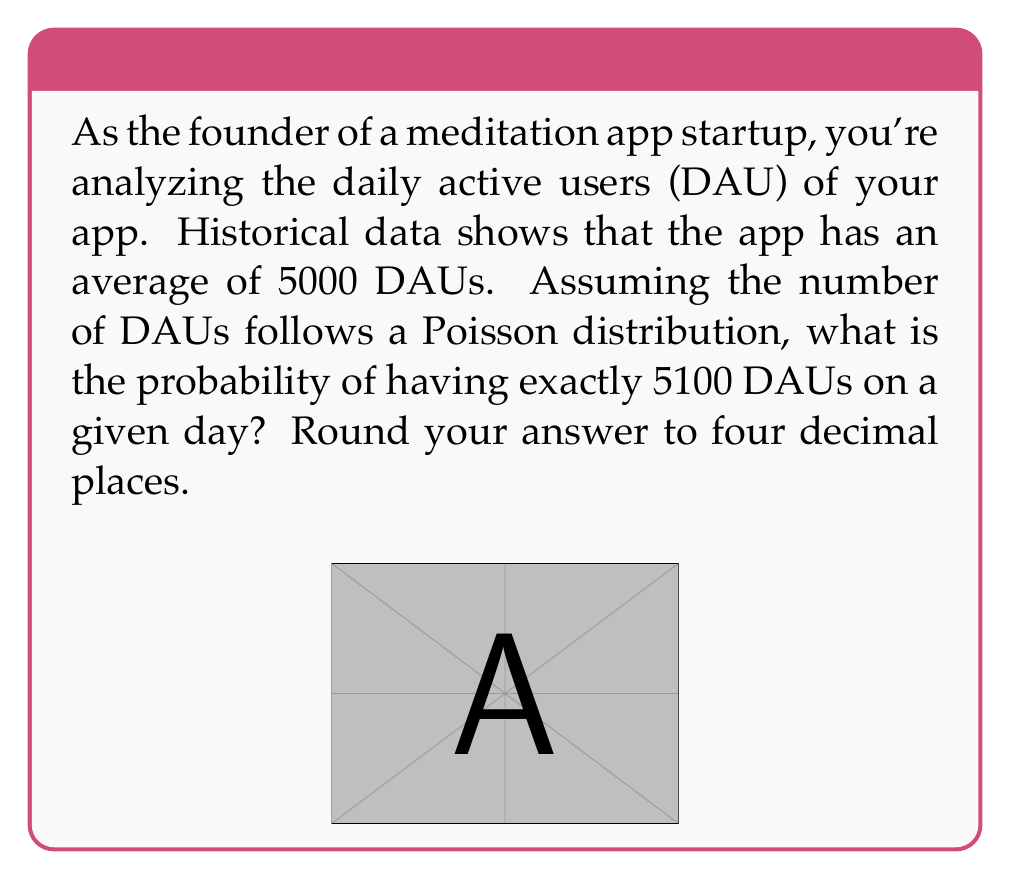Teach me how to tackle this problem. Let's approach this step-by-step:

1) The Poisson distribution is given by the formula:

   $$P(X = k) = \frac{e^{-\lambda} \lambda^k}{k!}$$

   where $\lambda$ is the average rate of occurrence and $k$ is the number of occurrences we're interested in.

2) In this case:
   $\lambda = 5000$ (average DAUs)
   $k = 5100$ (the specific number of DAUs we're calculating the probability for)

3) Plugging these values into the formula:

   $$P(X = 5100) = \frac{e^{-5000} 5000^{5100}}{5100!}$$

4) This calculation involves very large numbers, so we'll use logarithms to simplify:

   $$\ln(P(X = 5100)) = -5000 + 5100 \ln(5000) - \ln(5100!)$$

5) Using Stirling's approximation for the factorial:

   $$\ln(5100!) \approx 5100 \ln(5100) - 5100$$

6) Substituting this back:

   $$\ln(P(X = 5100)) \approx -5000 + 5100 \ln(5000) - (5100 \ln(5100) - 5100)$$

7) Calculating this (using a calculator or computer):

   $$\ln(P(X = 5100)) \approx -8.5648$$

8) Taking the exponential of both sides:

   $$P(X = 5100) \approx e^{-8.5648} \approx 0.0001905$$

9) Rounding to four decimal places:

   $$P(X = 5100) \approx 0.0002$$
Answer: 0.0002 